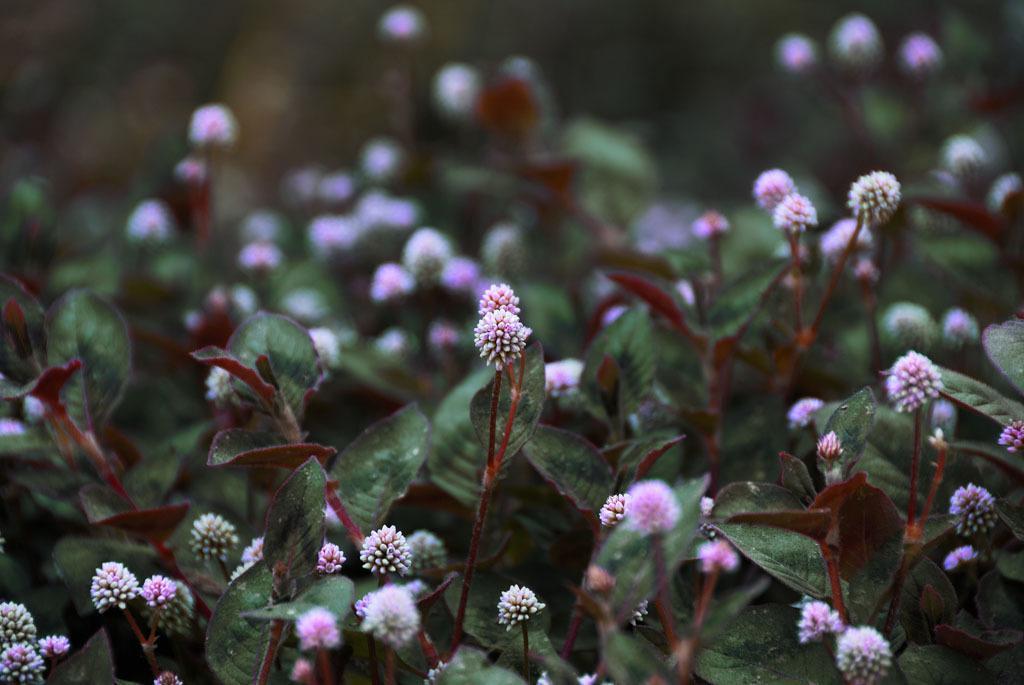How would you summarize this image in a sentence or two? In this image I see green leaves and pink color flowers on the stems and I can also see few white color flowers and it is blurred in the background. 